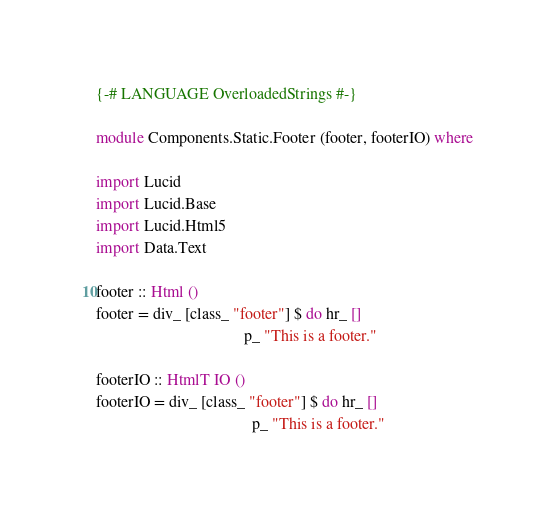Convert code to text. <code><loc_0><loc_0><loc_500><loc_500><_Haskell_>{-# LANGUAGE OverloadedStrings #-}

module Components.Static.Footer (footer, footerIO) where 

import Lucid
import Lucid.Base
import Lucid.Html5
import Data.Text

footer :: Html ()
footer = div_ [class_ "footer"] $ do hr_ []
                                     p_ "This is a footer."

footerIO :: HtmlT IO ()
footerIO = div_ [class_ "footer"] $ do hr_ []
                                       p_ "This is a footer."</code> 